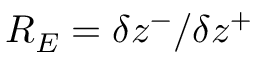<formula> <loc_0><loc_0><loc_500><loc_500>R _ { E } = \delta z ^ { - } / \delta z ^ { + }</formula> 